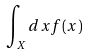Convert formula to latex. <formula><loc_0><loc_0><loc_500><loc_500>\int _ { X } d x f ( x )</formula> 